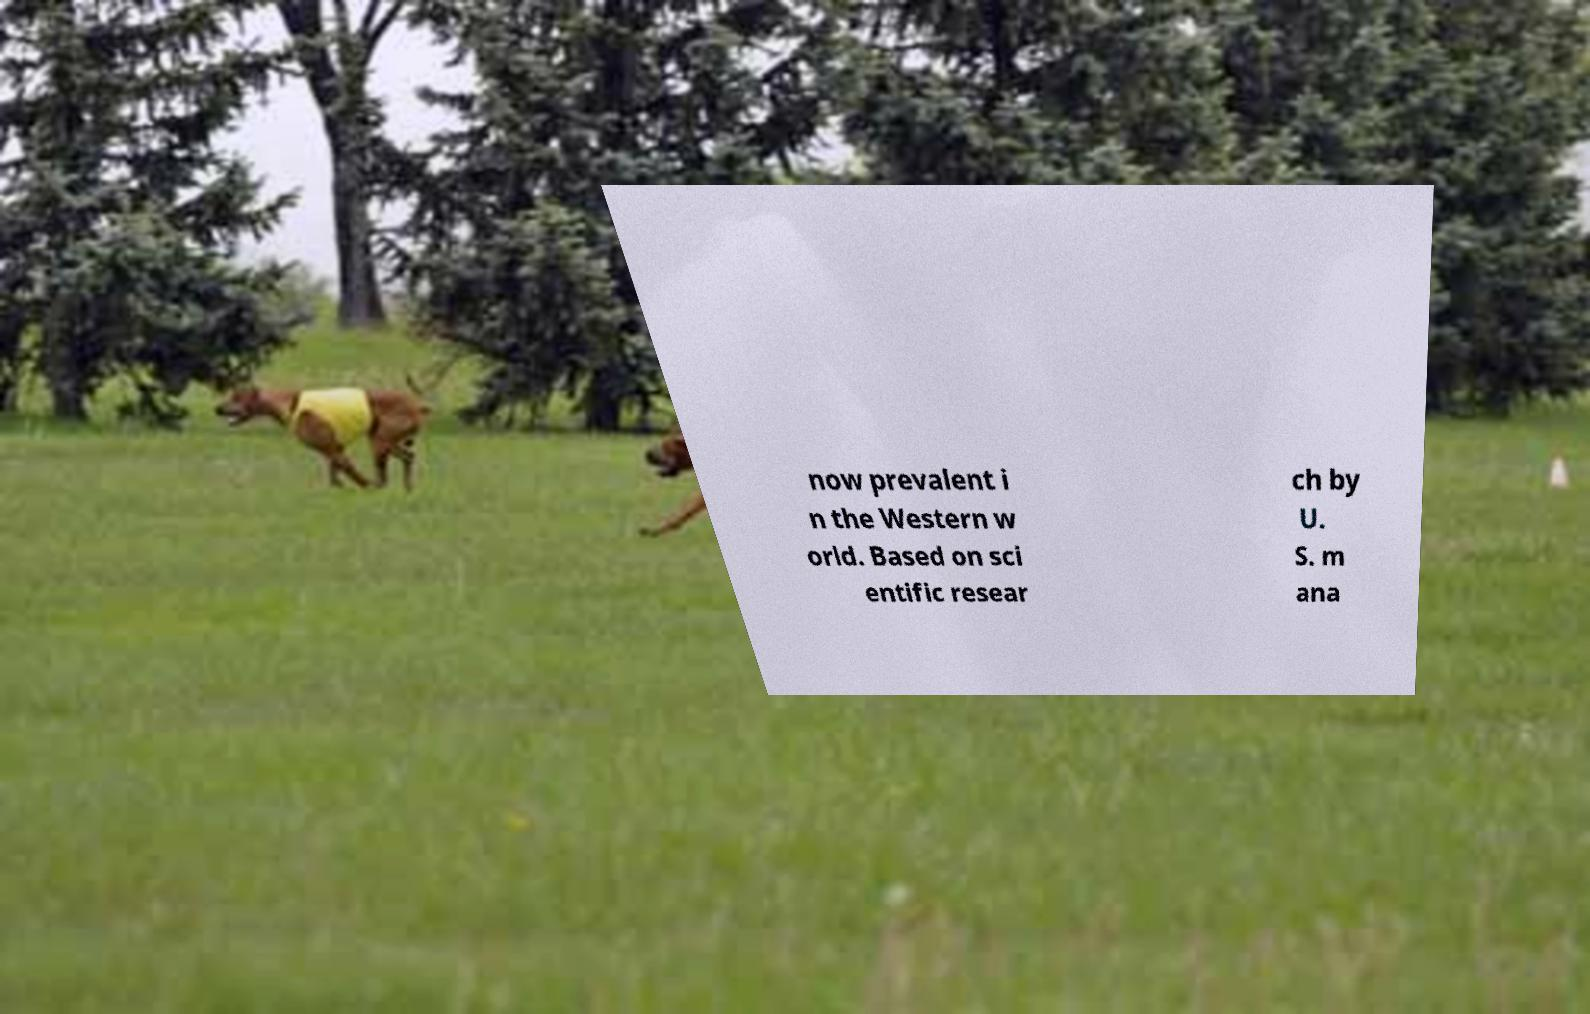Please read and relay the text visible in this image. What does it say? now prevalent i n the Western w orld. Based on sci entific resear ch by U. S. m ana 